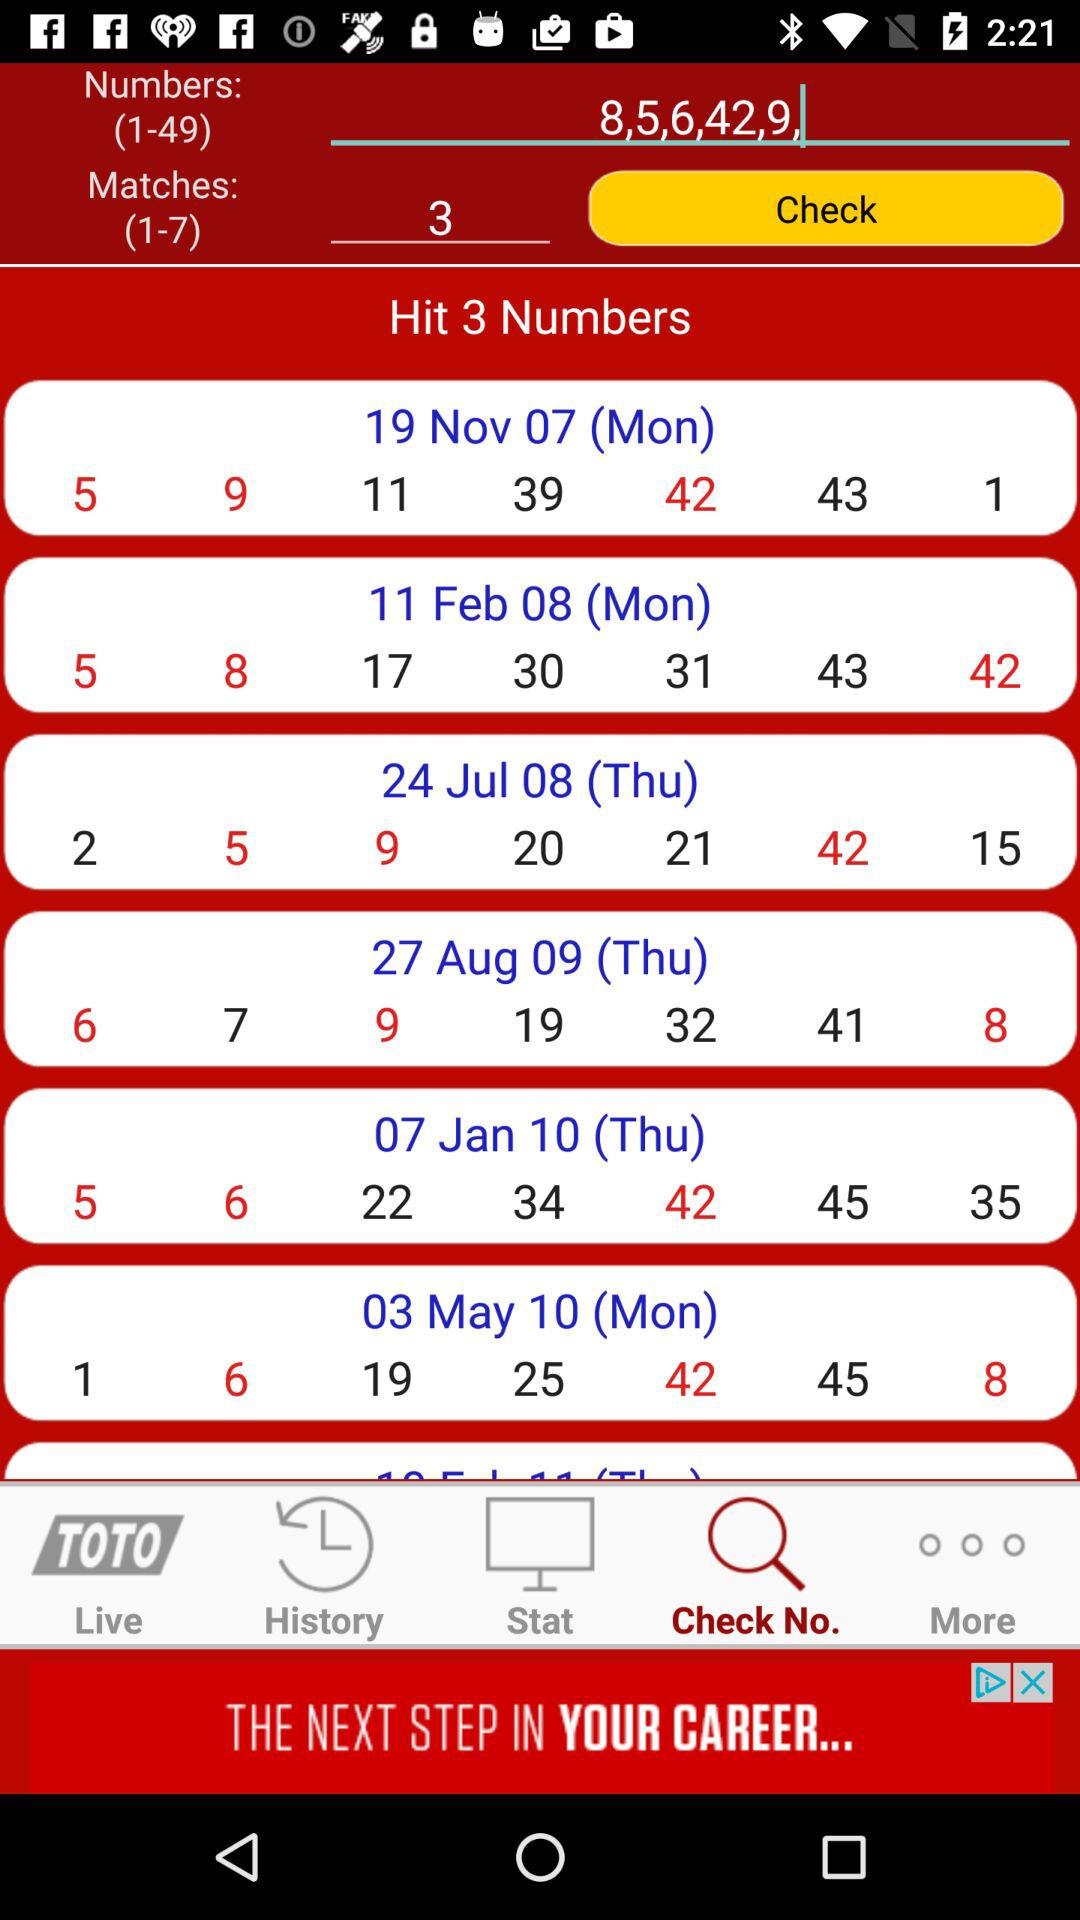What was the day on "03 May 10"? The day was Monday. 